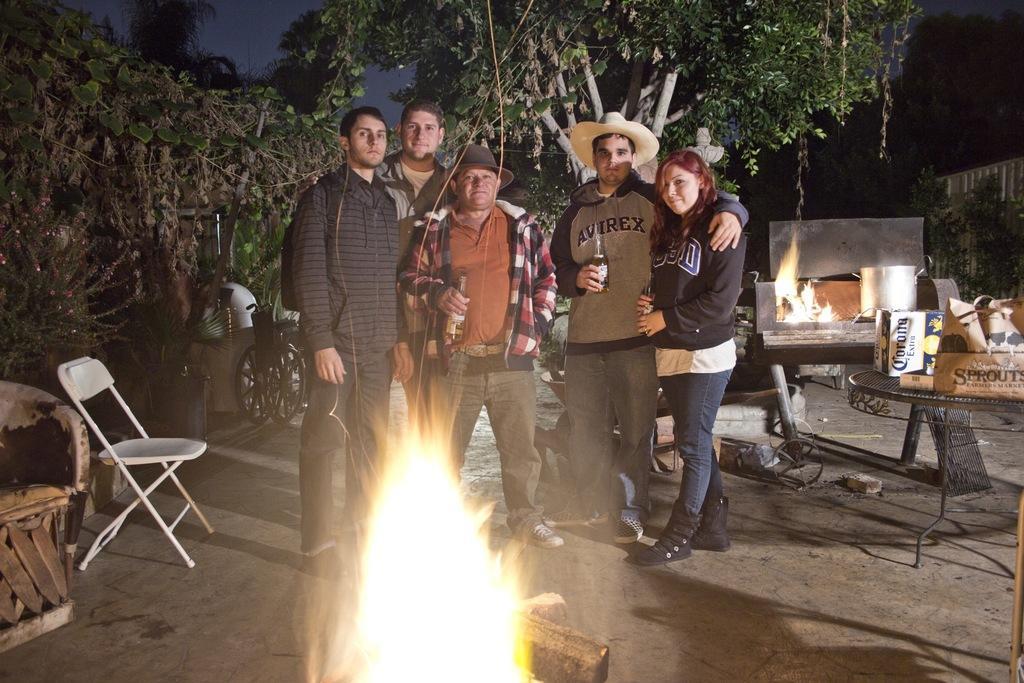In one or two sentences, can you explain what this image depicts? In this image I can see group of people standing wearing brown shirt holding a bottle. I can also see a chair in white color, in front I can see fire. Background I can see trees in green color. 